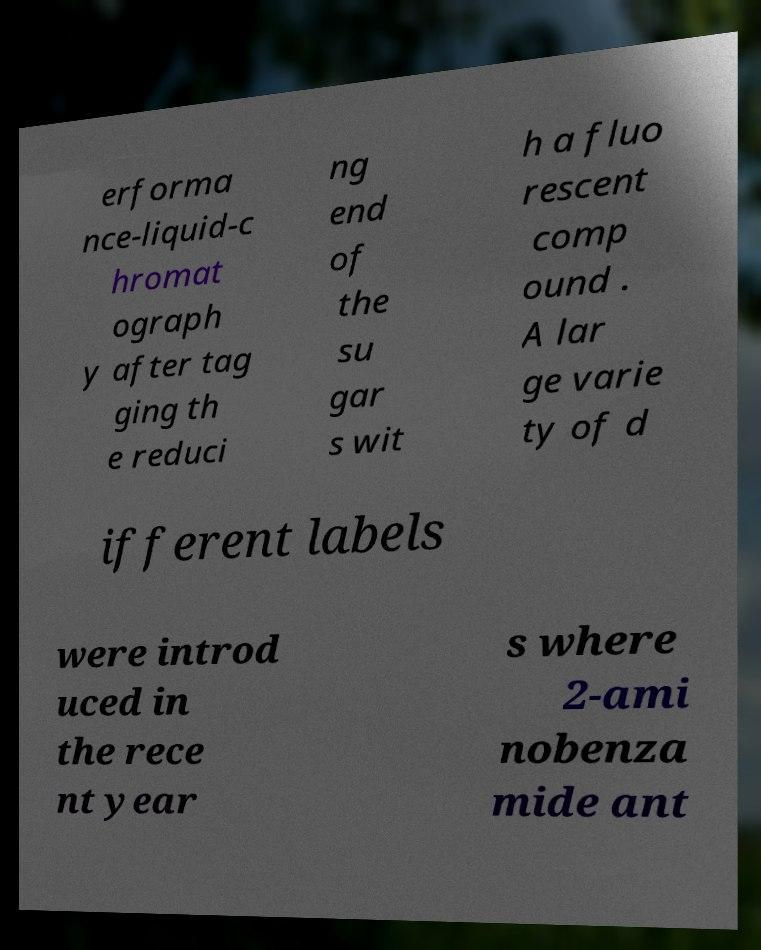Can you read and provide the text displayed in the image?This photo seems to have some interesting text. Can you extract and type it out for me? erforma nce-liquid-c hromat ograph y after tag ging th e reduci ng end of the su gar s wit h a fluo rescent comp ound . A lar ge varie ty of d ifferent labels were introd uced in the rece nt year s where 2-ami nobenza mide ant 